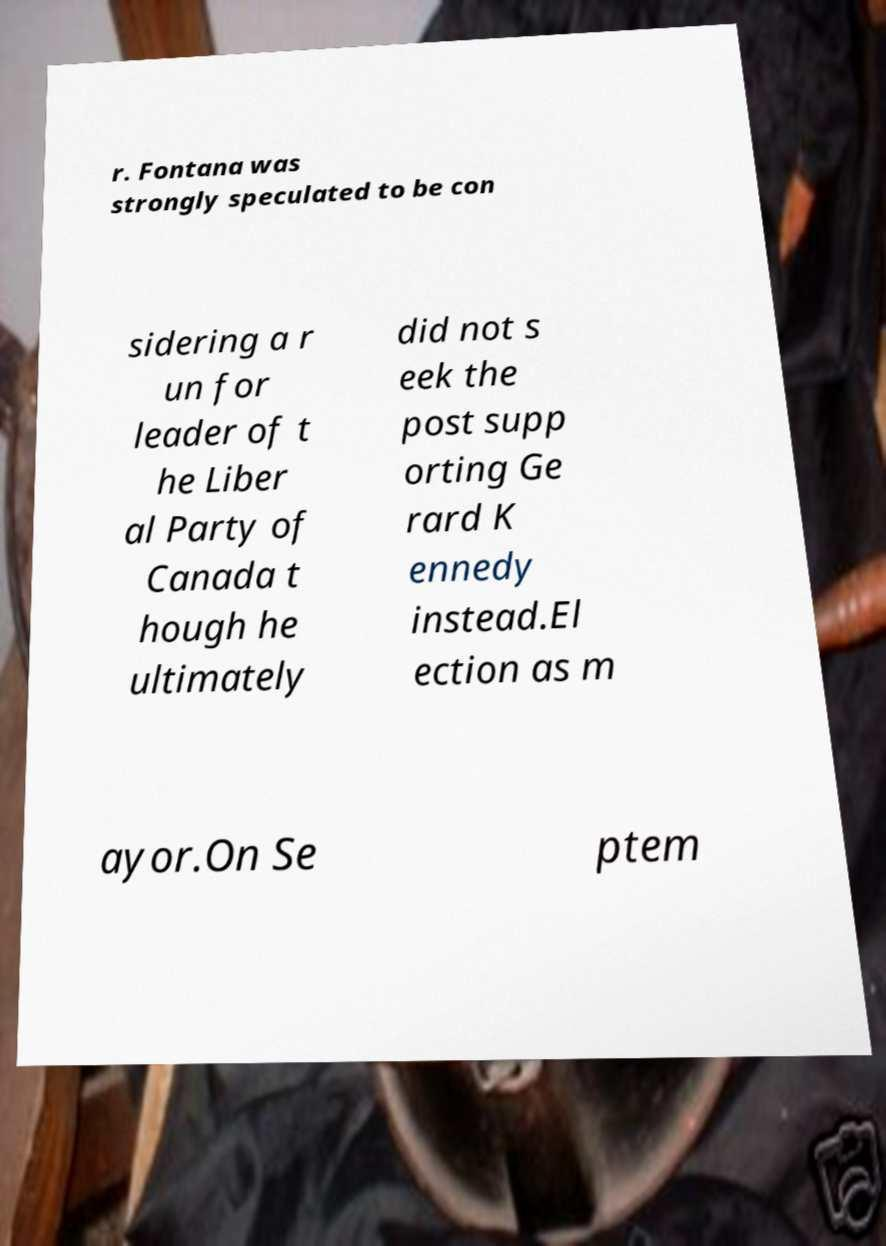For documentation purposes, I need the text within this image transcribed. Could you provide that? r. Fontana was strongly speculated to be con sidering a r un for leader of t he Liber al Party of Canada t hough he ultimately did not s eek the post supp orting Ge rard K ennedy instead.El ection as m ayor.On Se ptem 